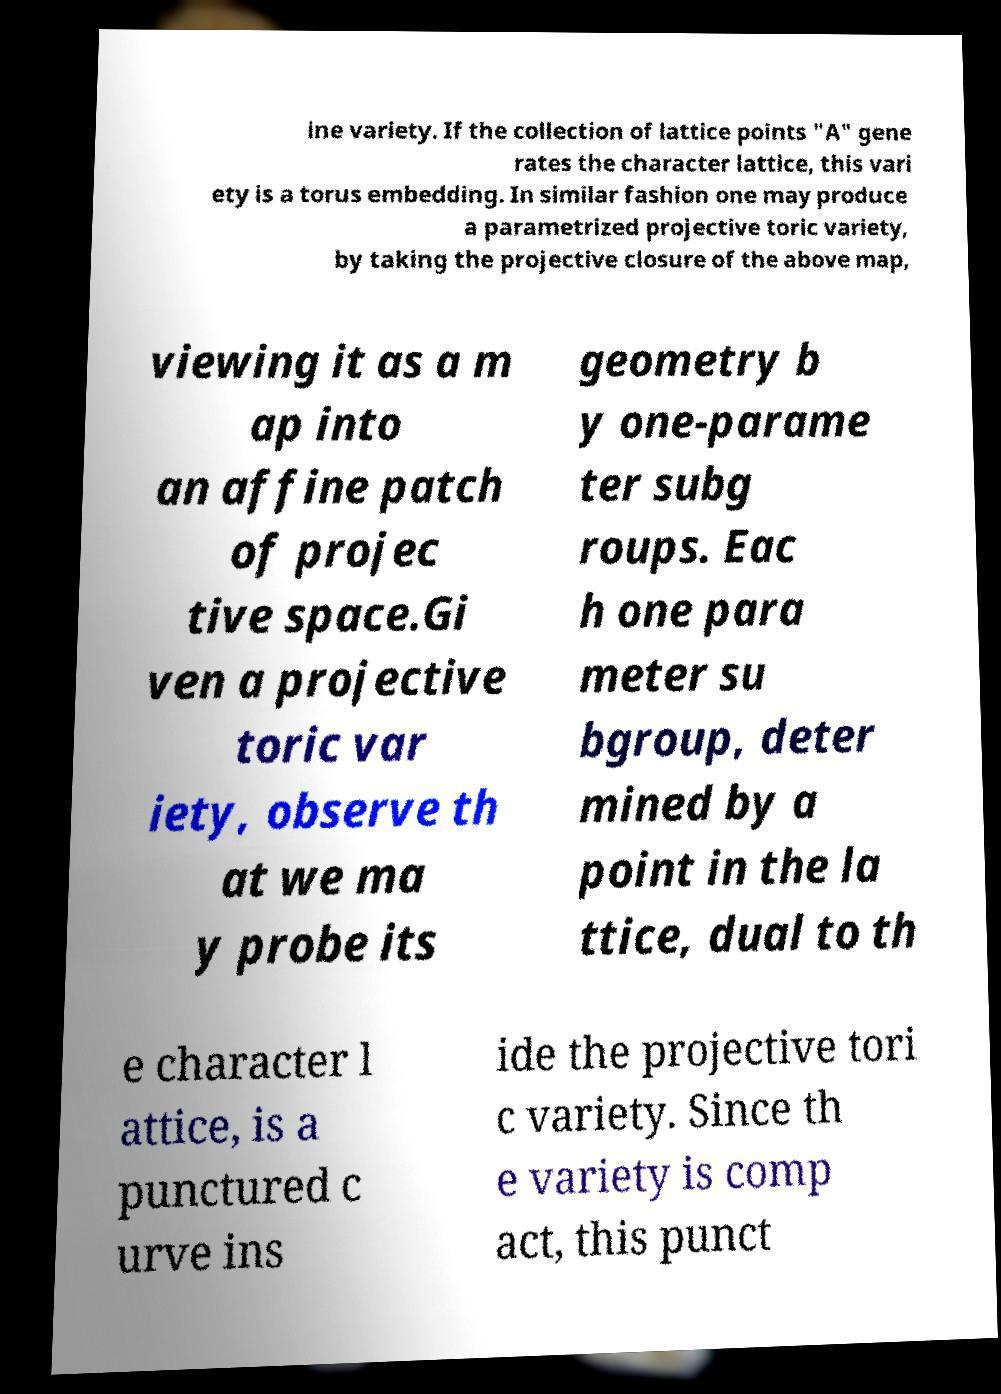Please identify and transcribe the text found in this image. ine variety. If the collection of lattice points "A" gene rates the character lattice, this vari ety is a torus embedding. In similar fashion one may produce a parametrized projective toric variety, by taking the projective closure of the above map, viewing it as a m ap into an affine patch of projec tive space.Gi ven a projective toric var iety, observe th at we ma y probe its geometry b y one-parame ter subg roups. Eac h one para meter su bgroup, deter mined by a point in the la ttice, dual to th e character l attice, is a punctured c urve ins ide the projective tori c variety. Since th e variety is comp act, this punct 